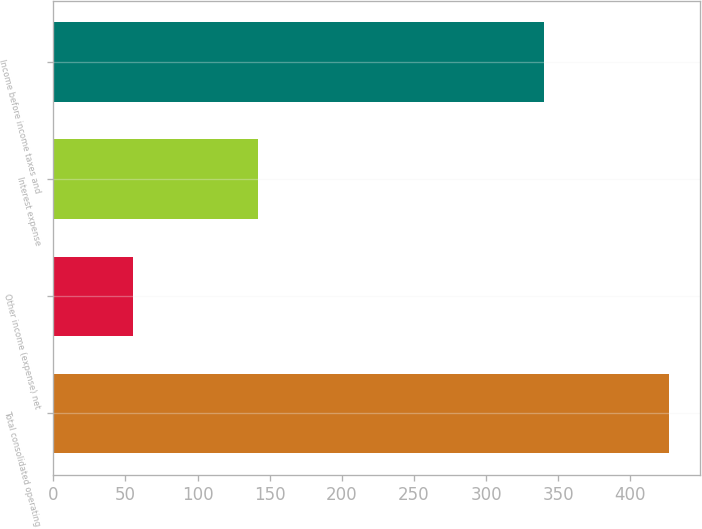<chart> <loc_0><loc_0><loc_500><loc_500><bar_chart><fcel>Total consolidated operating<fcel>Other income (expense) net<fcel>Interest expense<fcel>Income before income taxes and<nl><fcel>427<fcel>55<fcel>142<fcel>340<nl></chart> 